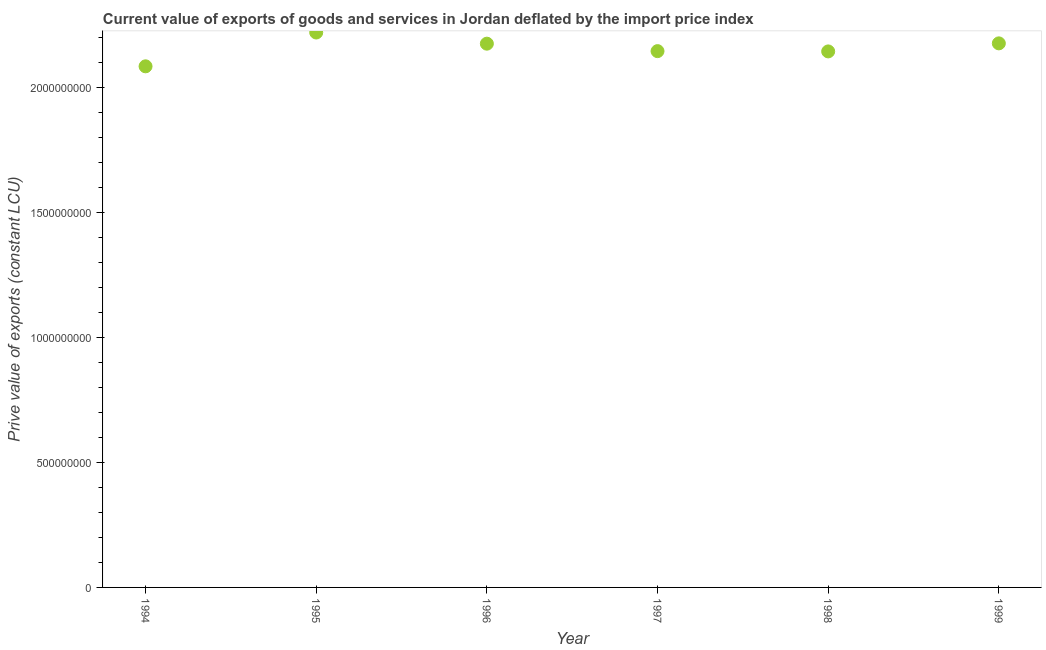What is the price value of exports in 1998?
Ensure brevity in your answer.  2.15e+09. Across all years, what is the maximum price value of exports?
Give a very brief answer. 2.22e+09. Across all years, what is the minimum price value of exports?
Ensure brevity in your answer.  2.09e+09. In which year was the price value of exports minimum?
Your answer should be very brief. 1994. What is the sum of the price value of exports?
Your answer should be very brief. 1.30e+1. What is the difference between the price value of exports in 1994 and 1999?
Your answer should be compact. -9.19e+07. What is the average price value of exports per year?
Provide a short and direct response. 2.16e+09. What is the median price value of exports?
Your answer should be very brief. 2.16e+09. In how many years, is the price value of exports greater than 2100000000 LCU?
Offer a very short reply. 5. Do a majority of the years between 1996 and 1999 (inclusive) have price value of exports greater than 400000000 LCU?
Provide a short and direct response. Yes. What is the ratio of the price value of exports in 1995 to that in 1998?
Your answer should be very brief. 1.04. Is the difference between the price value of exports in 1994 and 1995 greater than the difference between any two years?
Your answer should be very brief. Yes. What is the difference between the highest and the second highest price value of exports?
Keep it short and to the point. 4.34e+07. Is the sum of the price value of exports in 1996 and 1998 greater than the maximum price value of exports across all years?
Give a very brief answer. Yes. What is the difference between the highest and the lowest price value of exports?
Give a very brief answer. 1.35e+08. In how many years, is the price value of exports greater than the average price value of exports taken over all years?
Keep it short and to the point. 3. Does the price value of exports monotonically increase over the years?
Your response must be concise. No. Are the values on the major ticks of Y-axis written in scientific E-notation?
Ensure brevity in your answer.  No. What is the title of the graph?
Ensure brevity in your answer.  Current value of exports of goods and services in Jordan deflated by the import price index. What is the label or title of the Y-axis?
Give a very brief answer. Prive value of exports (constant LCU). What is the Prive value of exports (constant LCU) in 1994?
Your answer should be very brief. 2.09e+09. What is the Prive value of exports (constant LCU) in 1995?
Offer a terse response. 2.22e+09. What is the Prive value of exports (constant LCU) in 1996?
Make the answer very short. 2.18e+09. What is the Prive value of exports (constant LCU) in 1997?
Keep it short and to the point. 2.15e+09. What is the Prive value of exports (constant LCU) in 1998?
Your response must be concise. 2.15e+09. What is the Prive value of exports (constant LCU) in 1999?
Offer a very short reply. 2.18e+09. What is the difference between the Prive value of exports (constant LCU) in 1994 and 1995?
Your answer should be compact. -1.35e+08. What is the difference between the Prive value of exports (constant LCU) in 1994 and 1996?
Give a very brief answer. -9.07e+07. What is the difference between the Prive value of exports (constant LCU) in 1994 and 1997?
Offer a terse response. -6.08e+07. What is the difference between the Prive value of exports (constant LCU) in 1994 and 1998?
Keep it short and to the point. -5.97e+07. What is the difference between the Prive value of exports (constant LCU) in 1994 and 1999?
Offer a terse response. -9.19e+07. What is the difference between the Prive value of exports (constant LCU) in 1995 and 1996?
Offer a very short reply. 4.46e+07. What is the difference between the Prive value of exports (constant LCU) in 1995 and 1997?
Make the answer very short. 7.45e+07. What is the difference between the Prive value of exports (constant LCU) in 1995 and 1998?
Offer a very short reply. 7.56e+07. What is the difference between the Prive value of exports (constant LCU) in 1995 and 1999?
Provide a succinct answer. 4.34e+07. What is the difference between the Prive value of exports (constant LCU) in 1996 and 1997?
Your answer should be compact. 2.98e+07. What is the difference between the Prive value of exports (constant LCU) in 1996 and 1998?
Provide a succinct answer. 3.10e+07. What is the difference between the Prive value of exports (constant LCU) in 1996 and 1999?
Give a very brief answer. -1.24e+06. What is the difference between the Prive value of exports (constant LCU) in 1997 and 1998?
Provide a short and direct response. 1.14e+06. What is the difference between the Prive value of exports (constant LCU) in 1997 and 1999?
Give a very brief answer. -3.11e+07. What is the difference between the Prive value of exports (constant LCU) in 1998 and 1999?
Provide a succinct answer. -3.22e+07. What is the ratio of the Prive value of exports (constant LCU) in 1994 to that in 1995?
Make the answer very short. 0.94. What is the ratio of the Prive value of exports (constant LCU) in 1994 to that in 1996?
Offer a very short reply. 0.96. What is the ratio of the Prive value of exports (constant LCU) in 1994 to that in 1999?
Provide a short and direct response. 0.96. What is the ratio of the Prive value of exports (constant LCU) in 1995 to that in 1996?
Your response must be concise. 1.02. What is the ratio of the Prive value of exports (constant LCU) in 1995 to that in 1997?
Offer a terse response. 1.03. What is the ratio of the Prive value of exports (constant LCU) in 1995 to that in 1998?
Give a very brief answer. 1.03. What is the ratio of the Prive value of exports (constant LCU) in 1996 to that in 1997?
Your answer should be compact. 1.01. What is the ratio of the Prive value of exports (constant LCU) in 1996 to that in 1998?
Your response must be concise. 1.01. What is the ratio of the Prive value of exports (constant LCU) in 1996 to that in 1999?
Your answer should be compact. 1. What is the ratio of the Prive value of exports (constant LCU) in 1997 to that in 1998?
Keep it short and to the point. 1. What is the ratio of the Prive value of exports (constant LCU) in 1997 to that in 1999?
Your response must be concise. 0.99. What is the ratio of the Prive value of exports (constant LCU) in 1998 to that in 1999?
Offer a terse response. 0.98. 